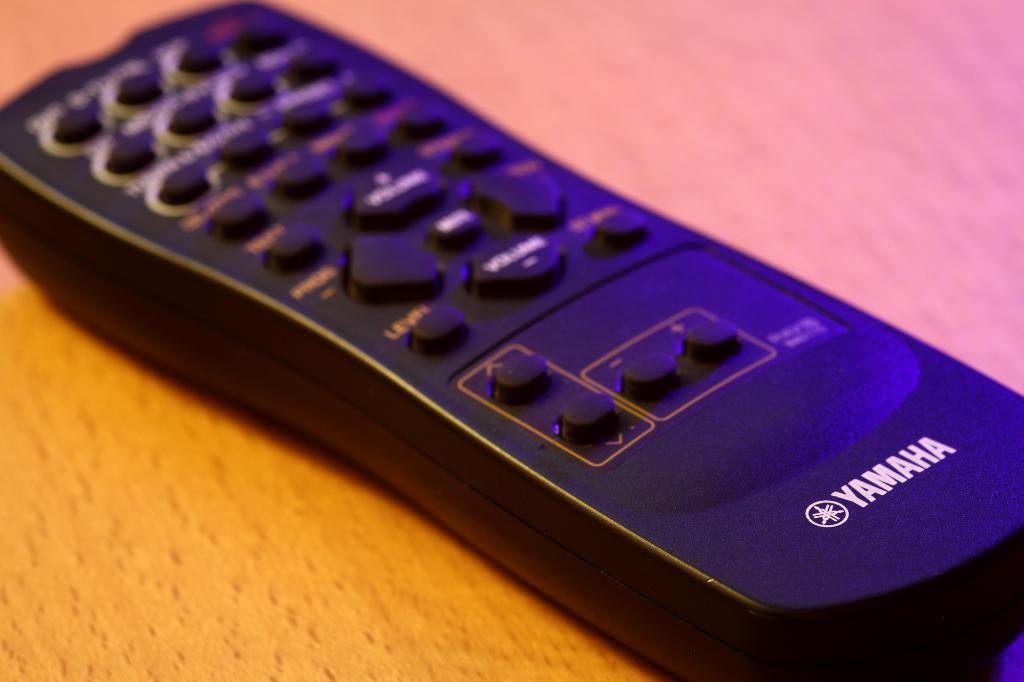What brand of tv does the remote belong to?
Ensure brevity in your answer.  Yamaha. 